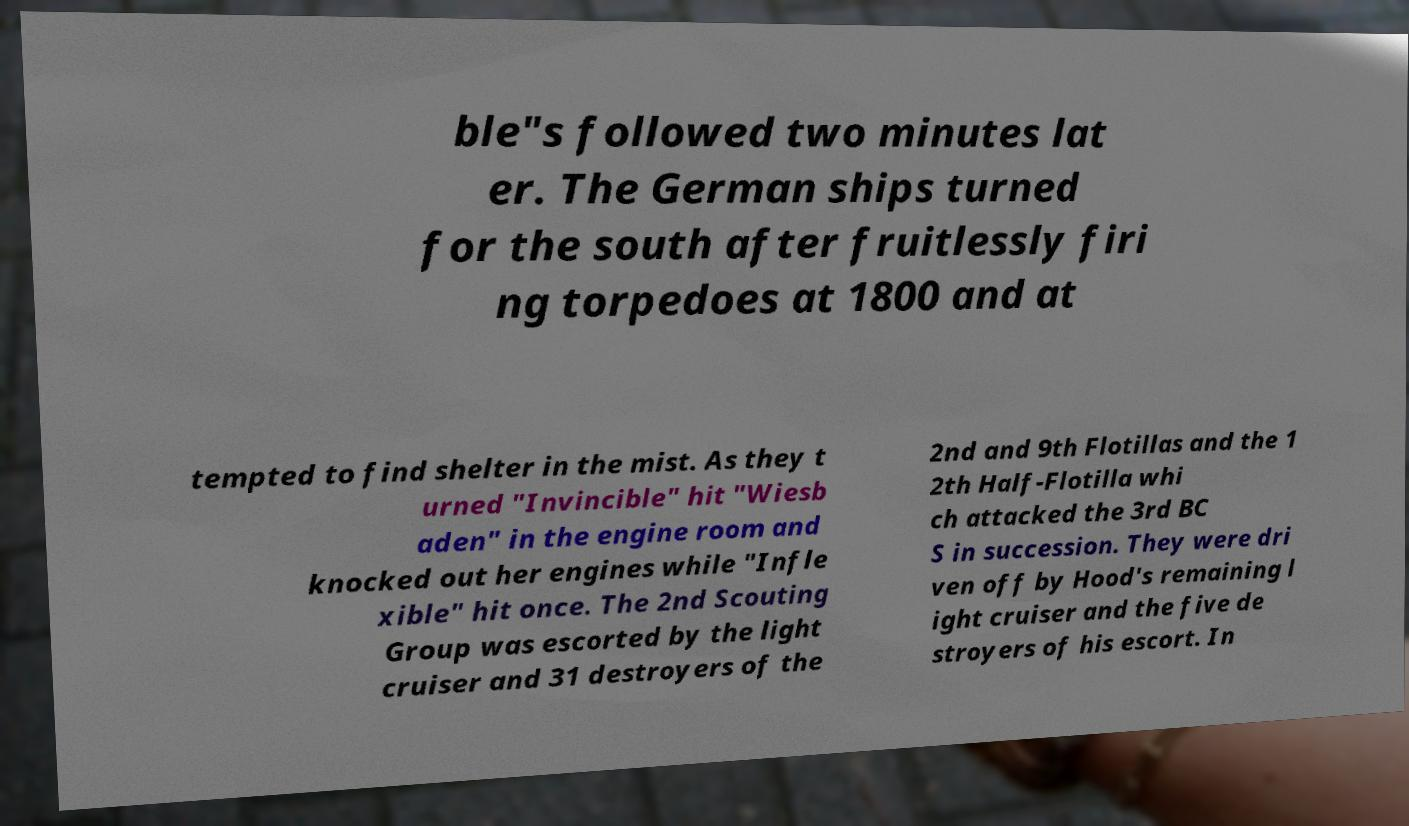Please identify and transcribe the text found in this image. ble"s followed two minutes lat er. The German ships turned for the south after fruitlessly firi ng torpedoes at 1800 and at tempted to find shelter in the mist. As they t urned "Invincible" hit "Wiesb aden" in the engine room and knocked out her engines while "Infle xible" hit once. The 2nd Scouting Group was escorted by the light cruiser and 31 destroyers of the 2nd and 9th Flotillas and the 1 2th Half-Flotilla whi ch attacked the 3rd BC S in succession. They were dri ven off by Hood's remaining l ight cruiser and the five de stroyers of his escort. In 